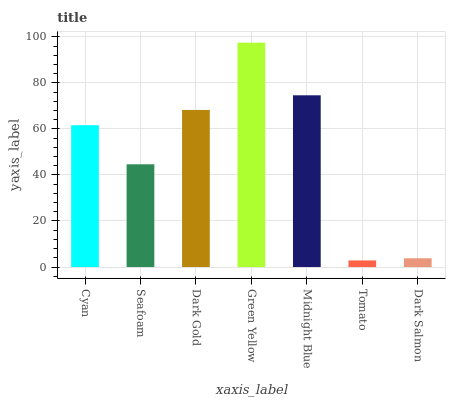Is Tomato the minimum?
Answer yes or no. Yes. Is Green Yellow the maximum?
Answer yes or no. Yes. Is Seafoam the minimum?
Answer yes or no. No. Is Seafoam the maximum?
Answer yes or no. No. Is Cyan greater than Seafoam?
Answer yes or no. Yes. Is Seafoam less than Cyan?
Answer yes or no. Yes. Is Seafoam greater than Cyan?
Answer yes or no. No. Is Cyan less than Seafoam?
Answer yes or no. No. Is Cyan the high median?
Answer yes or no. Yes. Is Cyan the low median?
Answer yes or no. Yes. Is Midnight Blue the high median?
Answer yes or no. No. Is Midnight Blue the low median?
Answer yes or no. No. 